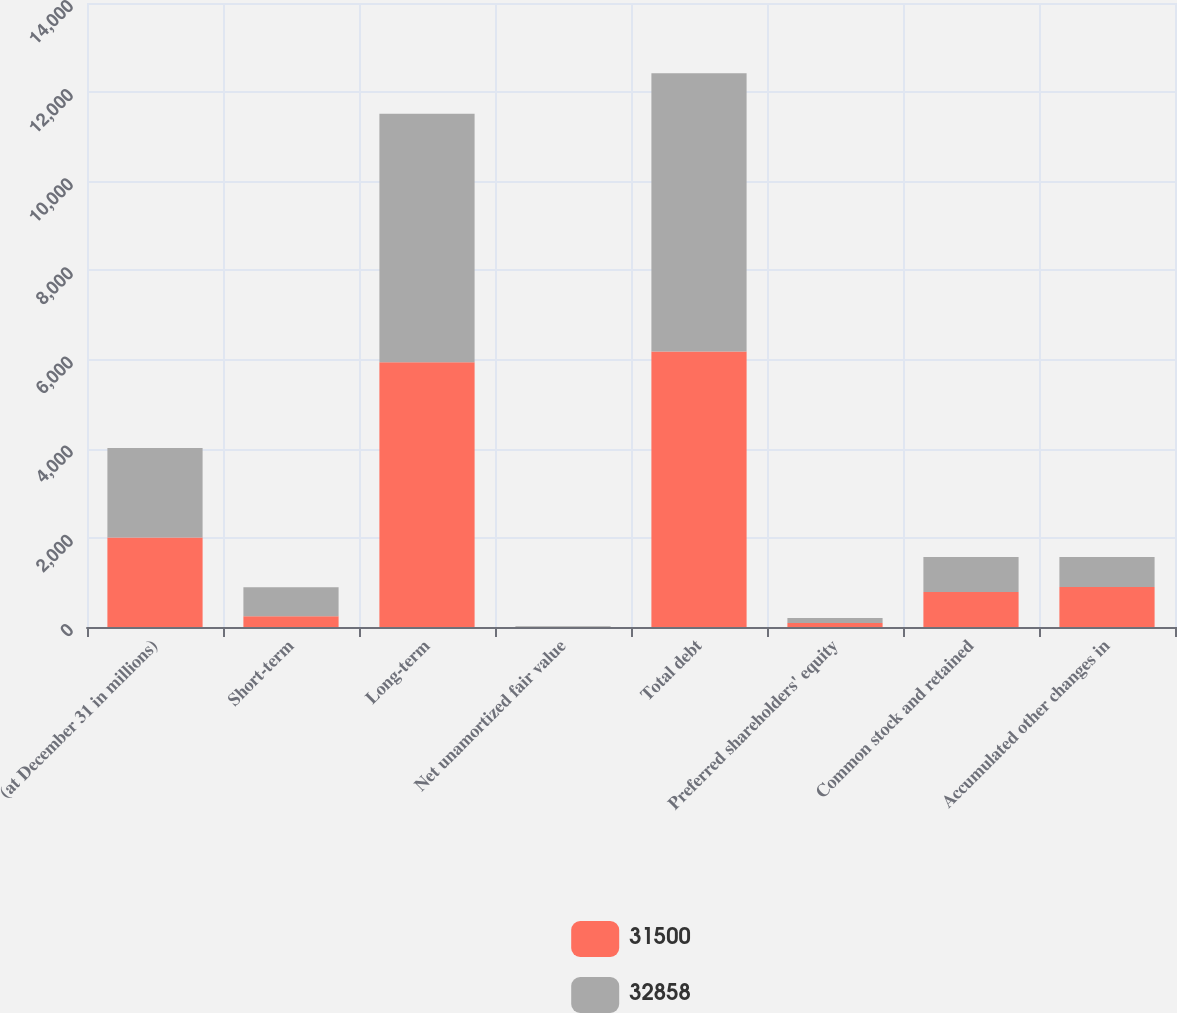Convert chart. <chart><loc_0><loc_0><loc_500><loc_500><stacked_bar_chart><ecel><fcel>(at December 31 in millions)<fcel>Short-term<fcel>Long-term<fcel>Net unamortized fair value<fcel>Total debt<fcel>Preferred shareholders' equity<fcel>Common stock and retained<fcel>Accumulated other changes in<nl><fcel>31500<fcel>2008<fcel>242<fcel>5938<fcel>1<fcel>6181<fcel>89<fcel>785<fcel>900<nl><fcel>32858<fcel>2007<fcel>649<fcel>5577<fcel>16<fcel>6242<fcel>112<fcel>785<fcel>670<nl></chart> 